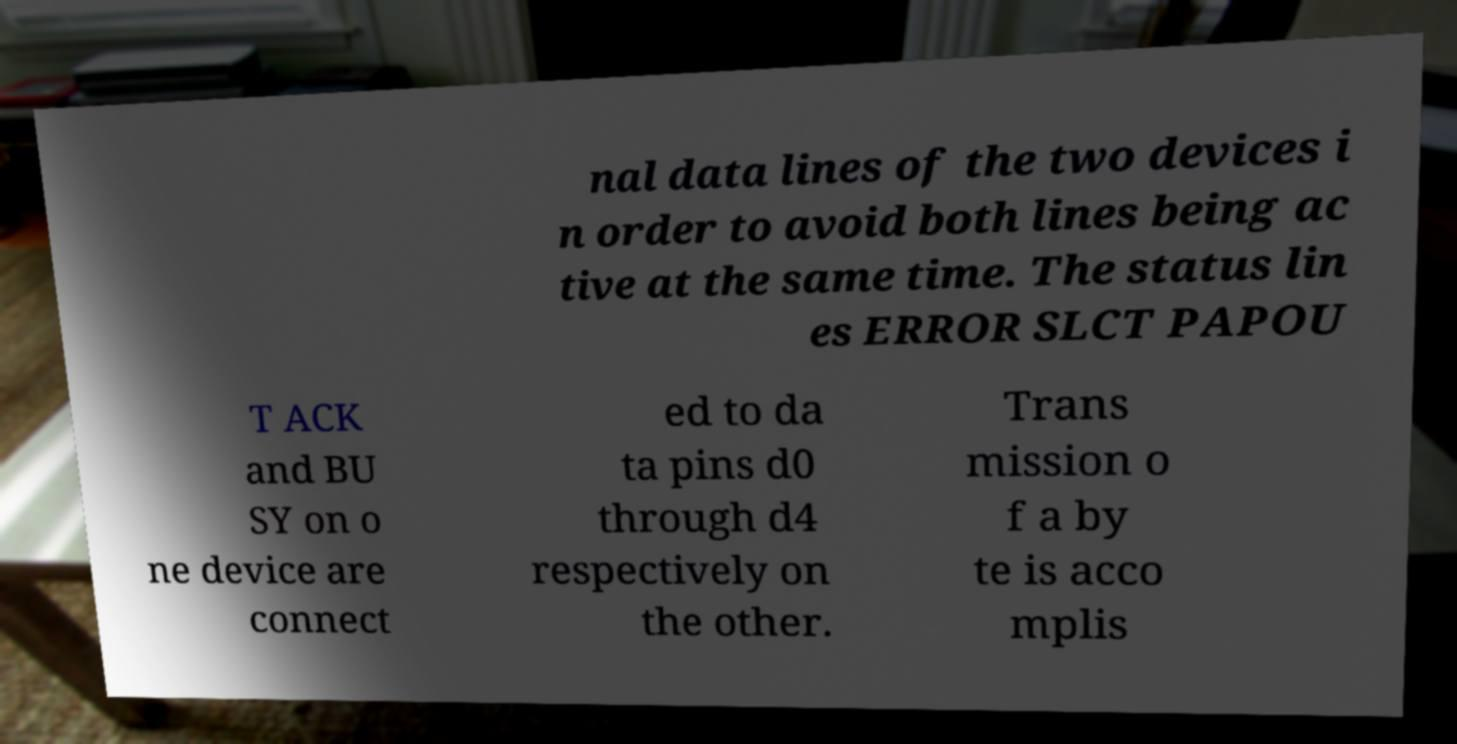For documentation purposes, I need the text within this image transcribed. Could you provide that? nal data lines of the two devices i n order to avoid both lines being ac tive at the same time. The status lin es ERROR SLCT PAPOU T ACK and BU SY on o ne device are connect ed to da ta pins d0 through d4 respectively on the other. Trans mission o f a by te is acco mplis 